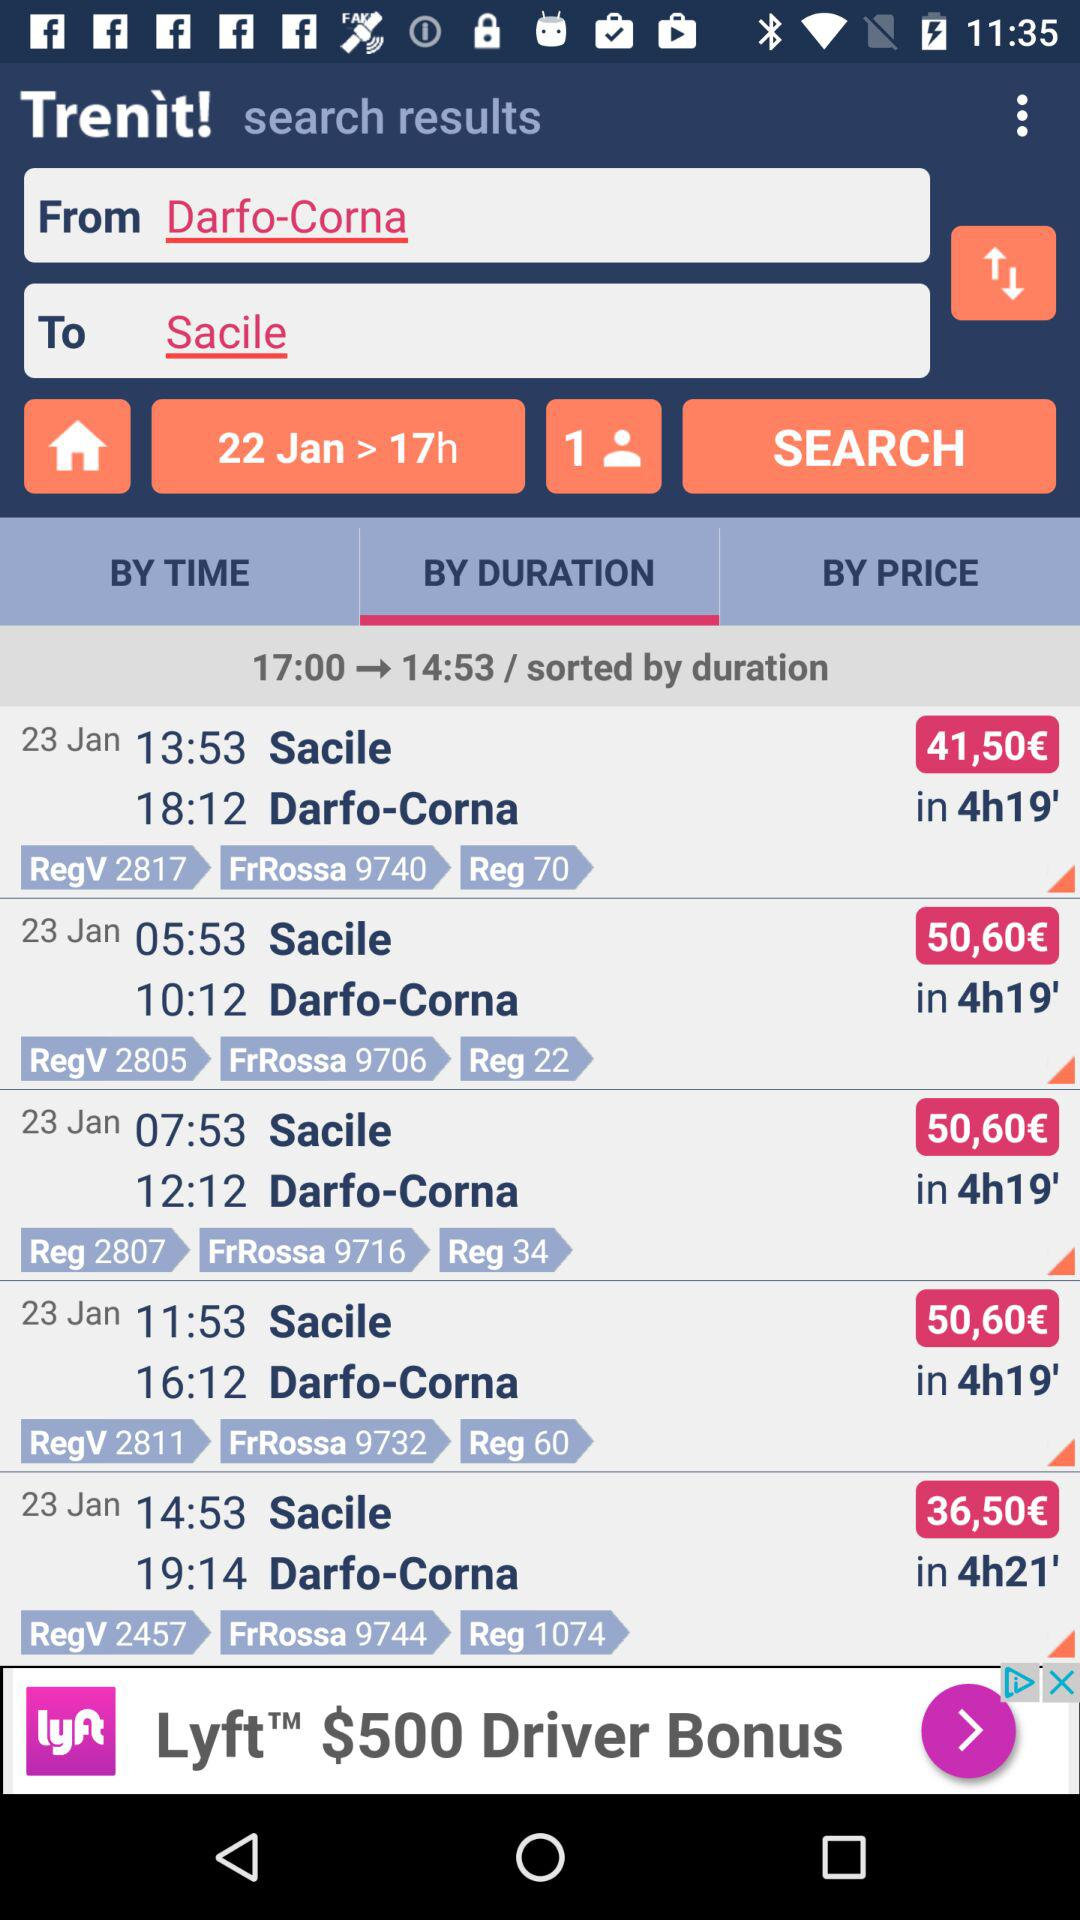Which tab has been selected? The tab "BY DURATION" has been selected. 